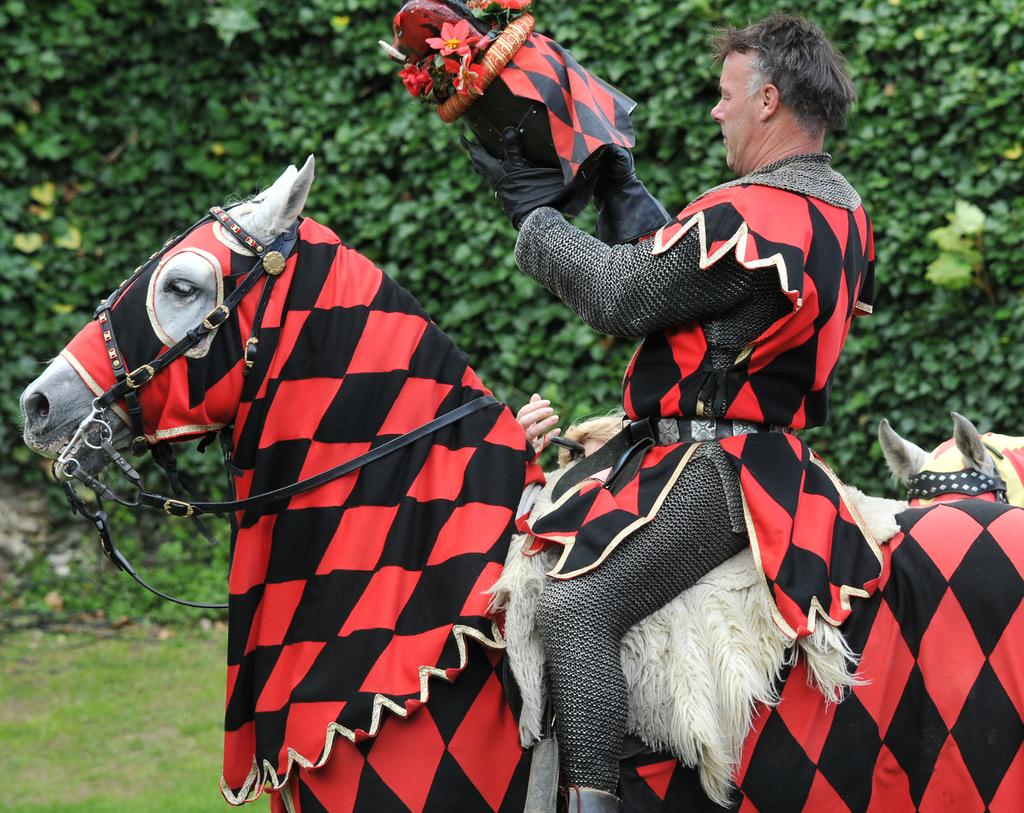What is the main subject of the image? There is a man in the image. What is the man doing in the image? The man is riding a horse. What is the man wearing in the image? The man is wearing costumes. What can be seen in the background of the image? There are trees in the background of the image. What type of terrain is visible at the bottom of the image? There is grass visible at the bottom of the image. How many muscles can be seen on the horse in the image? The image does not show the muscles of the horse; it only shows the man riding the horse. What type of tent is set up near the trees in the image? There is no tent present in the image; it only features a man riding a horse with trees in the background. 